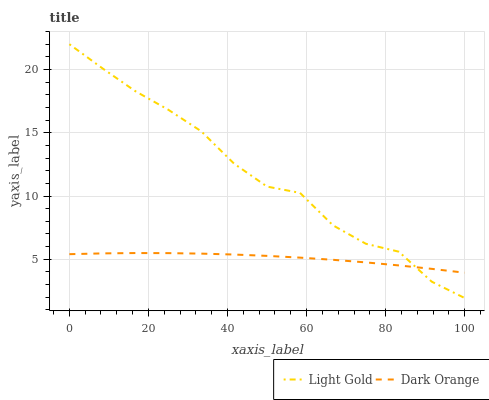Does Dark Orange have the minimum area under the curve?
Answer yes or no. Yes. Does Light Gold have the maximum area under the curve?
Answer yes or no. Yes. Does Light Gold have the minimum area under the curve?
Answer yes or no. No. Is Dark Orange the smoothest?
Answer yes or no. Yes. Is Light Gold the roughest?
Answer yes or no. Yes. Is Light Gold the smoothest?
Answer yes or no. No. Does Light Gold have the highest value?
Answer yes or no. Yes. Does Dark Orange intersect Light Gold?
Answer yes or no. Yes. Is Dark Orange less than Light Gold?
Answer yes or no. No. Is Dark Orange greater than Light Gold?
Answer yes or no. No. 